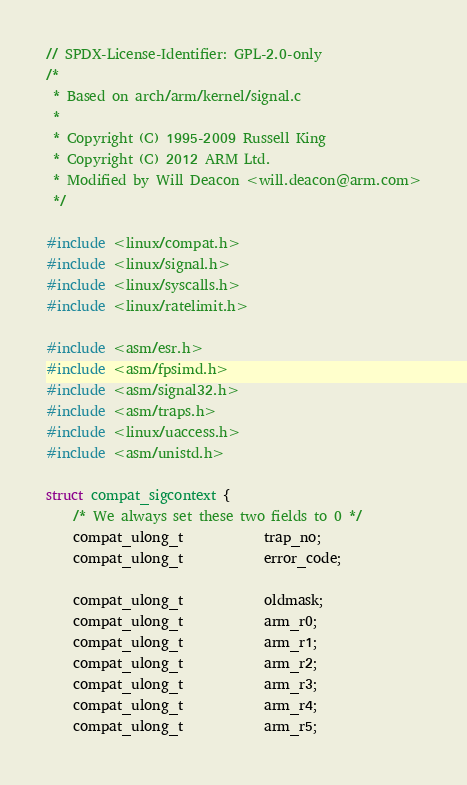Convert code to text. <code><loc_0><loc_0><loc_500><loc_500><_C_>// SPDX-License-Identifier: GPL-2.0-only
/*
 * Based on arch/arm/kernel/signal.c
 *
 * Copyright (C) 1995-2009 Russell King
 * Copyright (C) 2012 ARM Ltd.
 * Modified by Will Deacon <will.deacon@arm.com>
 */

#include <linux/compat.h>
#include <linux/signal.h>
#include <linux/syscalls.h>
#include <linux/ratelimit.h>

#include <asm/esr.h>
#include <asm/fpsimd.h>
#include <asm/signal32.h>
#include <asm/traps.h>
#include <linux/uaccess.h>
#include <asm/unistd.h>

struct compat_sigcontext {
	/* We always set these two fields to 0 */
	compat_ulong_t			trap_no;
	compat_ulong_t			error_code;

	compat_ulong_t			oldmask;
	compat_ulong_t			arm_r0;
	compat_ulong_t			arm_r1;
	compat_ulong_t			arm_r2;
	compat_ulong_t			arm_r3;
	compat_ulong_t			arm_r4;
	compat_ulong_t			arm_r5;</code> 